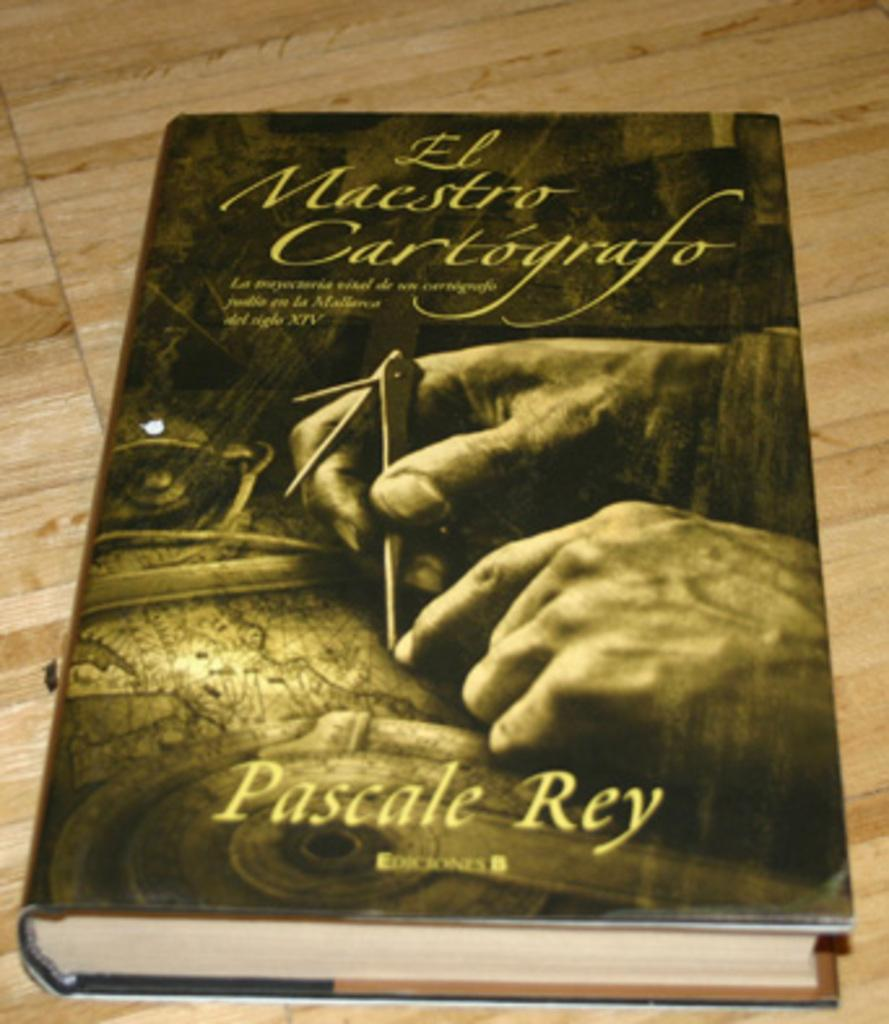Provide a one-sentence caption for the provided image. A close up iof a book called El Maestro Cartografo by Pascale Ray has the image of a man marking out a map on its cover. 